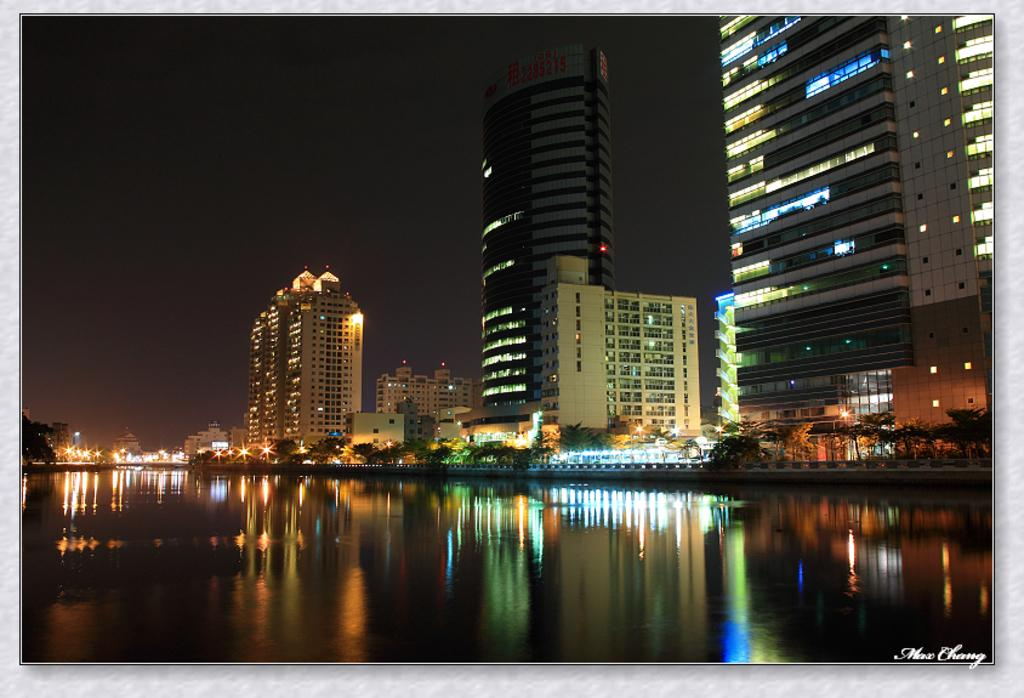What type of structures can be seen in the image? There are buildings in the image. What natural elements are present in the image? There are trees and water visible in the image. What might be used for illumination in the image? There are lights in the image. What can be seen in the background of the image? The sky is visible in the background of the image. What type of bread is being used to test the water's temperature in the image? There is no bread or testing activity present in the image; it features buildings, trees, water, lights, and the sky. 